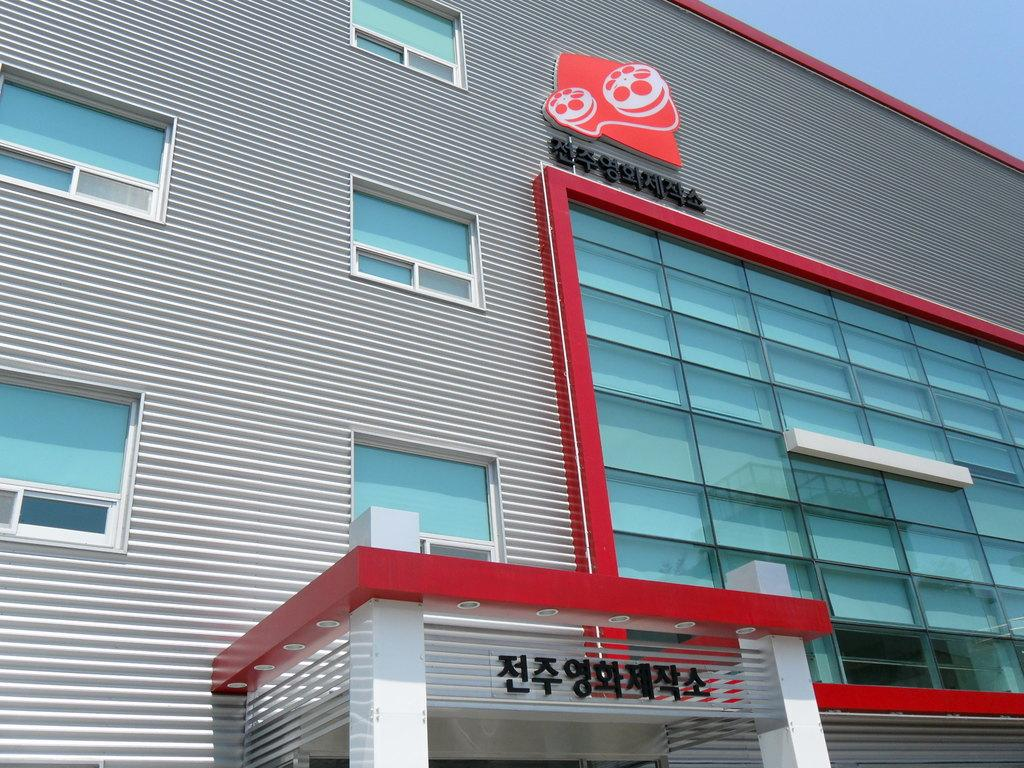What type of structure is in the image? There is a commercial building in the image. What feature can be seen on the building? The building has windows. Is there any text visible on the building? Yes, there is text written on the building. Can you see a snake slithering near the building in the image? No, there is no snake present in the image. 